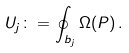<formula> <loc_0><loc_0><loc_500><loc_500>U _ { j } \colon = \oint _ { b _ { j } } \Omega ( P ) \, .</formula> 